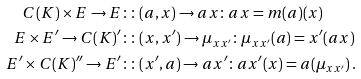Convert formula to latex. <formula><loc_0><loc_0><loc_500><loc_500>C ( K ) \times E \rightarrow E & \colon \colon ( a , x ) \rightarrow a x \colon a x = m ( a ) ( x ) \\ E \times E ^ { \prime } \rightarrow C ( K ) ^ { \prime } & \colon \colon ( x , x ^ { \prime } ) \rightarrow \mu _ { x x ^ { \prime } } \colon \mu _ { x x ^ { \prime } } ( a ) = x ^ { \prime } ( a x ) \\ E ^ { \prime } \times C ( K ) ^ { \prime \prime } \rightarrow E ^ { \prime } & \colon \colon ( x ^ { \prime } , a ) \rightarrow a x ^ { \prime } \colon a x ^ { \prime } ( x ) = a ( \mu _ { x x ^ { \prime } } ) \, .</formula> 